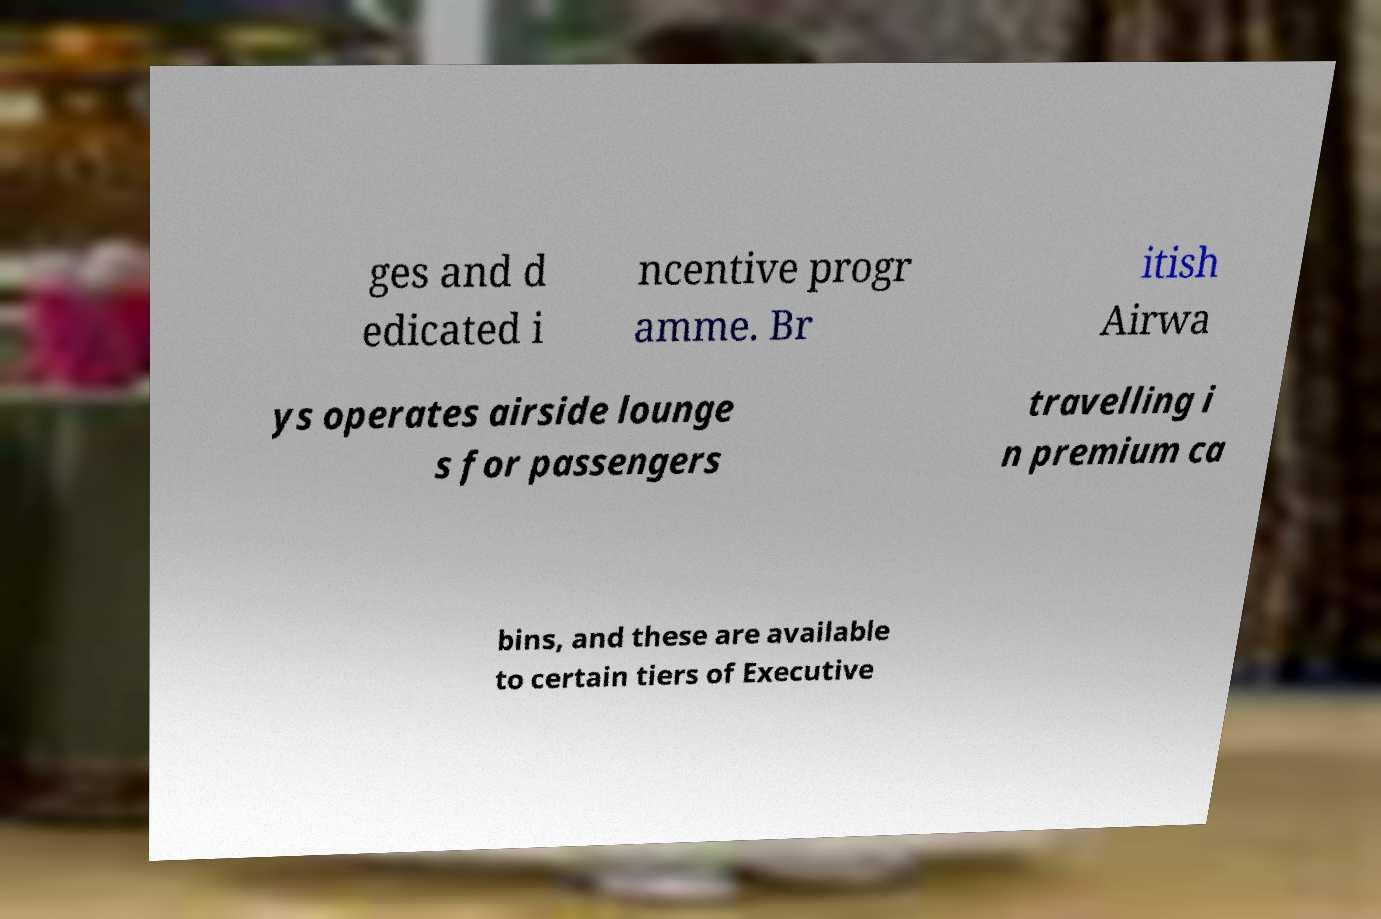Can you read and provide the text displayed in the image?This photo seems to have some interesting text. Can you extract and type it out for me? ges and d edicated i ncentive progr amme. Br itish Airwa ys operates airside lounge s for passengers travelling i n premium ca bins, and these are available to certain tiers of Executive 